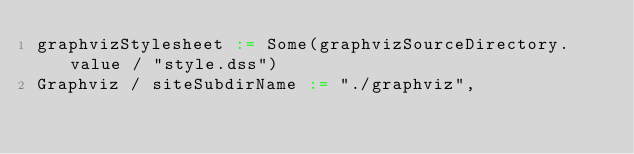<code> <loc_0><loc_0><loc_500><loc_500><_Scala_>graphvizStylesheet := Some(graphvizSourceDirectory.value / "style.dss")
Graphviz / siteSubdirName := "./graphviz",
</code> 